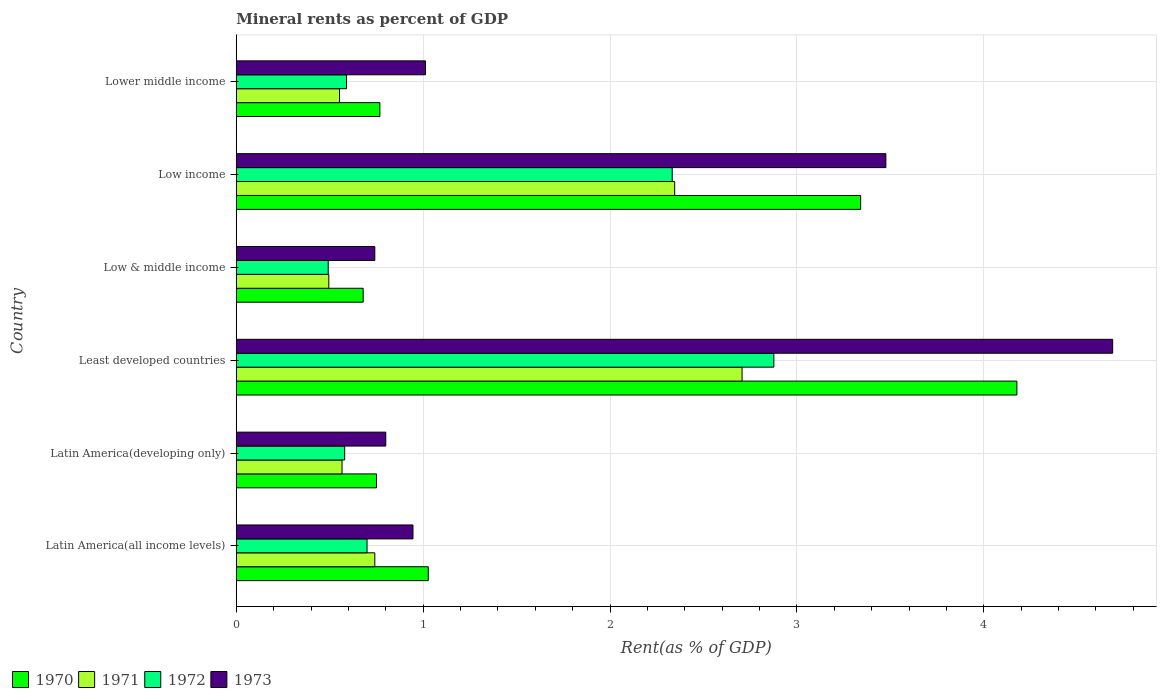How many groups of bars are there?
Your answer should be compact. 6. How many bars are there on the 5th tick from the top?
Give a very brief answer. 4. What is the label of the 3rd group of bars from the top?
Offer a very short reply. Low & middle income. What is the mineral rent in 1972 in Low & middle income?
Offer a terse response. 0.49. Across all countries, what is the maximum mineral rent in 1972?
Your answer should be very brief. 2.88. Across all countries, what is the minimum mineral rent in 1972?
Your response must be concise. 0.49. In which country was the mineral rent in 1972 maximum?
Ensure brevity in your answer.  Least developed countries. What is the total mineral rent in 1973 in the graph?
Make the answer very short. 11.67. What is the difference between the mineral rent in 1971 in Latin America(all income levels) and that in Low & middle income?
Provide a succinct answer. 0.25. What is the difference between the mineral rent in 1972 in Latin America(developing only) and the mineral rent in 1973 in Lower middle income?
Provide a succinct answer. -0.43. What is the average mineral rent in 1973 per country?
Offer a very short reply. 1.94. What is the difference between the mineral rent in 1972 and mineral rent in 1971 in Low & middle income?
Keep it short and to the point. -0. In how many countries, is the mineral rent in 1970 greater than 1.4 %?
Your answer should be very brief. 2. What is the ratio of the mineral rent in 1970 in Latin America(developing only) to that in Low income?
Your answer should be compact. 0.22. Is the mineral rent in 1971 in Latin America(all income levels) less than that in Low income?
Offer a very short reply. Yes. What is the difference between the highest and the second highest mineral rent in 1970?
Your answer should be very brief. 0.84. What is the difference between the highest and the lowest mineral rent in 1972?
Give a very brief answer. 2.38. In how many countries, is the mineral rent in 1972 greater than the average mineral rent in 1972 taken over all countries?
Provide a succinct answer. 2. What does the 2nd bar from the bottom in Latin America(developing only) represents?
Ensure brevity in your answer.  1971. Are all the bars in the graph horizontal?
Provide a succinct answer. Yes. How many countries are there in the graph?
Offer a very short reply. 6. Are the values on the major ticks of X-axis written in scientific E-notation?
Provide a short and direct response. No. Where does the legend appear in the graph?
Offer a very short reply. Bottom left. How are the legend labels stacked?
Offer a very short reply. Horizontal. What is the title of the graph?
Ensure brevity in your answer.  Mineral rents as percent of GDP. Does "2015" appear as one of the legend labels in the graph?
Your response must be concise. No. What is the label or title of the X-axis?
Offer a very short reply. Rent(as % of GDP). What is the Rent(as % of GDP) in 1970 in Latin America(all income levels)?
Offer a terse response. 1.03. What is the Rent(as % of GDP) of 1971 in Latin America(all income levels)?
Your answer should be very brief. 0.74. What is the Rent(as % of GDP) of 1972 in Latin America(all income levels)?
Your answer should be very brief. 0.7. What is the Rent(as % of GDP) of 1973 in Latin America(all income levels)?
Your answer should be very brief. 0.95. What is the Rent(as % of GDP) in 1970 in Latin America(developing only)?
Offer a terse response. 0.75. What is the Rent(as % of GDP) in 1971 in Latin America(developing only)?
Make the answer very short. 0.57. What is the Rent(as % of GDP) in 1972 in Latin America(developing only)?
Ensure brevity in your answer.  0.58. What is the Rent(as % of GDP) in 1973 in Latin America(developing only)?
Give a very brief answer. 0.8. What is the Rent(as % of GDP) of 1970 in Least developed countries?
Your response must be concise. 4.18. What is the Rent(as % of GDP) in 1971 in Least developed countries?
Provide a short and direct response. 2.71. What is the Rent(as % of GDP) of 1972 in Least developed countries?
Offer a terse response. 2.88. What is the Rent(as % of GDP) in 1973 in Least developed countries?
Your answer should be compact. 4.69. What is the Rent(as % of GDP) in 1970 in Low & middle income?
Your response must be concise. 0.68. What is the Rent(as % of GDP) of 1971 in Low & middle income?
Offer a terse response. 0.5. What is the Rent(as % of GDP) in 1972 in Low & middle income?
Keep it short and to the point. 0.49. What is the Rent(as % of GDP) of 1973 in Low & middle income?
Your answer should be very brief. 0.74. What is the Rent(as % of GDP) of 1970 in Low income?
Ensure brevity in your answer.  3.34. What is the Rent(as % of GDP) in 1971 in Low income?
Keep it short and to the point. 2.35. What is the Rent(as % of GDP) in 1972 in Low income?
Make the answer very short. 2.33. What is the Rent(as % of GDP) in 1973 in Low income?
Provide a short and direct response. 3.48. What is the Rent(as % of GDP) in 1970 in Lower middle income?
Offer a very short reply. 0.77. What is the Rent(as % of GDP) of 1971 in Lower middle income?
Provide a short and direct response. 0.55. What is the Rent(as % of GDP) in 1972 in Lower middle income?
Make the answer very short. 0.59. What is the Rent(as % of GDP) of 1973 in Lower middle income?
Provide a short and direct response. 1.01. Across all countries, what is the maximum Rent(as % of GDP) of 1970?
Make the answer very short. 4.18. Across all countries, what is the maximum Rent(as % of GDP) in 1971?
Offer a terse response. 2.71. Across all countries, what is the maximum Rent(as % of GDP) of 1972?
Provide a succinct answer. 2.88. Across all countries, what is the maximum Rent(as % of GDP) in 1973?
Your answer should be compact. 4.69. Across all countries, what is the minimum Rent(as % of GDP) of 1970?
Ensure brevity in your answer.  0.68. Across all countries, what is the minimum Rent(as % of GDP) in 1971?
Make the answer very short. 0.5. Across all countries, what is the minimum Rent(as % of GDP) of 1972?
Ensure brevity in your answer.  0.49. Across all countries, what is the minimum Rent(as % of GDP) of 1973?
Your answer should be very brief. 0.74. What is the total Rent(as % of GDP) of 1970 in the graph?
Your answer should be very brief. 10.74. What is the total Rent(as % of GDP) of 1971 in the graph?
Your response must be concise. 7.41. What is the total Rent(as % of GDP) in 1972 in the graph?
Your response must be concise. 7.57. What is the total Rent(as % of GDP) in 1973 in the graph?
Provide a succinct answer. 11.67. What is the difference between the Rent(as % of GDP) of 1970 in Latin America(all income levels) and that in Latin America(developing only)?
Your response must be concise. 0.28. What is the difference between the Rent(as % of GDP) in 1971 in Latin America(all income levels) and that in Latin America(developing only)?
Provide a succinct answer. 0.18. What is the difference between the Rent(as % of GDP) in 1972 in Latin America(all income levels) and that in Latin America(developing only)?
Your answer should be very brief. 0.12. What is the difference between the Rent(as % of GDP) of 1973 in Latin America(all income levels) and that in Latin America(developing only)?
Offer a very short reply. 0.15. What is the difference between the Rent(as % of GDP) in 1970 in Latin America(all income levels) and that in Least developed countries?
Your answer should be compact. -3.15. What is the difference between the Rent(as % of GDP) in 1971 in Latin America(all income levels) and that in Least developed countries?
Offer a very short reply. -1.97. What is the difference between the Rent(as % of GDP) of 1972 in Latin America(all income levels) and that in Least developed countries?
Your answer should be compact. -2.18. What is the difference between the Rent(as % of GDP) of 1973 in Latin America(all income levels) and that in Least developed countries?
Your answer should be very brief. -3.74. What is the difference between the Rent(as % of GDP) of 1970 in Latin America(all income levels) and that in Low & middle income?
Give a very brief answer. 0.35. What is the difference between the Rent(as % of GDP) in 1971 in Latin America(all income levels) and that in Low & middle income?
Offer a very short reply. 0.25. What is the difference between the Rent(as % of GDP) of 1972 in Latin America(all income levels) and that in Low & middle income?
Offer a terse response. 0.21. What is the difference between the Rent(as % of GDP) in 1973 in Latin America(all income levels) and that in Low & middle income?
Ensure brevity in your answer.  0.2. What is the difference between the Rent(as % of GDP) in 1970 in Latin America(all income levels) and that in Low income?
Offer a very short reply. -2.31. What is the difference between the Rent(as % of GDP) of 1971 in Latin America(all income levels) and that in Low income?
Your answer should be very brief. -1.6. What is the difference between the Rent(as % of GDP) in 1972 in Latin America(all income levels) and that in Low income?
Your answer should be very brief. -1.63. What is the difference between the Rent(as % of GDP) of 1973 in Latin America(all income levels) and that in Low income?
Your answer should be compact. -2.53. What is the difference between the Rent(as % of GDP) in 1970 in Latin America(all income levels) and that in Lower middle income?
Give a very brief answer. 0.26. What is the difference between the Rent(as % of GDP) in 1971 in Latin America(all income levels) and that in Lower middle income?
Your answer should be very brief. 0.19. What is the difference between the Rent(as % of GDP) of 1972 in Latin America(all income levels) and that in Lower middle income?
Provide a succinct answer. 0.11. What is the difference between the Rent(as % of GDP) in 1973 in Latin America(all income levels) and that in Lower middle income?
Your response must be concise. -0.07. What is the difference between the Rent(as % of GDP) in 1970 in Latin America(developing only) and that in Least developed countries?
Give a very brief answer. -3.43. What is the difference between the Rent(as % of GDP) in 1971 in Latin America(developing only) and that in Least developed countries?
Provide a succinct answer. -2.14. What is the difference between the Rent(as % of GDP) of 1972 in Latin America(developing only) and that in Least developed countries?
Provide a succinct answer. -2.3. What is the difference between the Rent(as % of GDP) of 1973 in Latin America(developing only) and that in Least developed countries?
Your answer should be very brief. -3.89. What is the difference between the Rent(as % of GDP) of 1970 in Latin America(developing only) and that in Low & middle income?
Provide a short and direct response. 0.07. What is the difference between the Rent(as % of GDP) of 1971 in Latin America(developing only) and that in Low & middle income?
Your answer should be very brief. 0.07. What is the difference between the Rent(as % of GDP) of 1972 in Latin America(developing only) and that in Low & middle income?
Your answer should be very brief. 0.09. What is the difference between the Rent(as % of GDP) of 1973 in Latin America(developing only) and that in Low & middle income?
Your answer should be very brief. 0.06. What is the difference between the Rent(as % of GDP) in 1970 in Latin America(developing only) and that in Low income?
Keep it short and to the point. -2.59. What is the difference between the Rent(as % of GDP) of 1971 in Latin America(developing only) and that in Low income?
Offer a terse response. -1.78. What is the difference between the Rent(as % of GDP) of 1972 in Latin America(developing only) and that in Low income?
Your answer should be very brief. -1.75. What is the difference between the Rent(as % of GDP) of 1973 in Latin America(developing only) and that in Low income?
Provide a succinct answer. -2.68. What is the difference between the Rent(as % of GDP) of 1970 in Latin America(developing only) and that in Lower middle income?
Your answer should be compact. -0.02. What is the difference between the Rent(as % of GDP) of 1971 in Latin America(developing only) and that in Lower middle income?
Provide a short and direct response. 0.01. What is the difference between the Rent(as % of GDP) of 1972 in Latin America(developing only) and that in Lower middle income?
Give a very brief answer. -0.01. What is the difference between the Rent(as % of GDP) in 1973 in Latin America(developing only) and that in Lower middle income?
Give a very brief answer. -0.21. What is the difference between the Rent(as % of GDP) in 1970 in Least developed countries and that in Low & middle income?
Provide a short and direct response. 3.5. What is the difference between the Rent(as % of GDP) of 1971 in Least developed countries and that in Low & middle income?
Offer a very short reply. 2.21. What is the difference between the Rent(as % of GDP) of 1972 in Least developed countries and that in Low & middle income?
Keep it short and to the point. 2.38. What is the difference between the Rent(as % of GDP) in 1973 in Least developed countries and that in Low & middle income?
Provide a short and direct response. 3.95. What is the difference between the Rent(as % of GDP) in 1970 in Least developed countries and that in Low income?
Keep it short and to the point. 0.84. What is the difference between the Rent(as % of GDP) in 1971 in Least developed countries and that in Low income?
Provide a short and direct response. 0.36. What is the difference between the Rent(as % of GDP) of 1972 in Least developed countries and that in Low income?
Your answer should be very brief. 0.54. What is the difference between the Rent(as % of GDP) in 1973 in Least developed countries and that in Low income?
Give a very brief answer. 1.21. What is the difference between the Rent(as % of GDP) of 1970 in Least developed countries and that in Lower middle income?
Keep it short and to the point. 3.41. What is the difference between the Rent(as % of GDP) in 1971 in Least developed countries and that in Lower middle income?
Your answer should be very brief. 2.15. What is the difference between the Rent(as % of GDP) in 1972 in Least developed countries and that in Lower middle income?
Provide a short and direct response. 2.29. What is the difference between the Rent(as % of GDP) of 1973 in Least developed countries and that in Lower middle income?
Your response must be concise. 3.68. What is the difference between the Rent(as % of GDP) in 1970 in Low & middle income and that in Low income?
Give a very brief answer. -2.66. What is the difference between the Rent(as % of GDP) in 1971 in Low & middle income and that in Low income?
Provide a succinct answer. -1.85. What is the difference between the Rent(as % of GDP) in 1972 in Low & middle income and that in Low income?
Give a very brief answer. -1.84. What is the difference between the Rent(as % of GDP) of 1973 in Low & middle income and that in Low income?
Ensure brevity in your answer.  -2.73. What is the difference between the Rent(as % of GDP) of 1970 in Low & middle income and that in Lower middle income?
Keep it short and to the point. -0.09. What is the difference between the Rent(as % of GDP) in 1971 in Low & middle income and that in Lower middle income?
Ensure brevity in your answer.  -0.06. What is the difference between the Rent(as % of GDP) in 1972 in Low & middle income and that in Lower middle income?
Offer a very short reply. -0.1. What is the difference between the Rent(as % of GDP) of 1973 in Low & middle income and that in Lower middle income?
Keep it short and to the point. -0.27. What is the difference between the Rent(as % of GDP) in 1970 in Low income and that in Lower middle income?
Make the answer very short. 2.57. What is the difference between the Rent(as % of GDP) of 1971 in Low income and that in Lower middle income?
Provide a succinct answer. 1.79. What is the difference between the Rent(as % of GDP) of 1972 in Low income and that in Lower middle income?
Your answer should be compact. 1.74. What is the difference between the Rent(as % of GDP) in 1973 in Low income and that in Lower middle income?
Offer a terse response. 2.46. What is the difference between the Rent(as % of GDP) of 1970 in Latin America(all income levels) and the Rent(as % of GDP) of 1971 in Latin America(developing only)?
Provide a succinct answer. 0.46. What is the difference between the Rent(as % of GDP) in 1970 in Latin America(all income levels) and the Rent(as % of GDP) in 1972 in Latin America(developing only)?
Offer a very short reply. 0.45. What is the difference between the Rent(as % of GDP) of 1970 in Latin America(all income levels) and the Rent(as % of GDP) of 1973 in Latin America(developing only)?
Your response must be concise. 0.23. What is the difference between the Rent(as % of GDP) of 1971 in Latin America(all income levels) and the Rent(as % of GDP) of 1972 in Latin America(developing only)?
Provide a short and direct response. 0.16. What is the difference between the Rent(as % of GDP) of 1971 in Latin America(all income levels) and the Rent(as % of GDP) of 1973 in Latin America(developing only)?
Your answer should be very brief. -0.06. What is the difference between the Rent(as % of GDP) of 1972 in Latin America(all income levels) and the Rent(as % of GDP) of 1973 in Latin America(developing only)?
Provide a short and direct response. -0.1. What is the difference between the Rent(as % of GDP) of 1970 in Latin America(all income levels) and the Rent(as % of GDP) of 1971 in Least developed countries?
Provide a short and direct response. -1.68. What is the difference between the Rent(as % of GDP) of 1970 in Latin America(all income levels) and the Rent(as % of GDP) of 1972 in Least developed countries?
Make the answer very short. -1.85. What is the difference between the Rent(as % of GDP) in 1970 in Latin America(all income levels) and the Rent(as % of GDP) in 1973 in Least developed countries?
Give a very brief answer. -3.66. What is the difference between the Rent(as % of GDP) of 1971 in Latin America(all income levels) and the Rent(as % of GDP) of 1972 in Least developed countries?
Offer a terse response. -2.14. What is the difference between the Rent(as % of GDP) of 1971 in Latin America(all income levels) and the Rent(as % of GDP) of 1973 in Least developed countries?
Provide a succinct answer. -3.95. What is the difference between the Rent(as % of GDP) of 1972 in Latin America(all income levels) and the Rent(as % of GDP) of 1973 in Least developed countries?
Give a very brief answer. -3.99. What is the difference between the Rent(as % of GDP) of 1970 in Latin America(all income levels) and the Rent(as % of GDP) of 1971 in Low & middle income?
Ensure brevity in your answer.  0.53. What is the difference between the Rent(as % of GDP) in 1970 in Latin America(all income levels) and the Rent(as % of GDP) in 1972 in Low & middle income?
Give a very brief answer. 0.54. What is the difference between the Rent(as % of GDP) of 1970 in Latin America(all income levels) and the Rent(as % of GDP) of 1973 in Low & middle income?
Your response must be concise. 0.29. What is the difference between the Rent(as % of GDP) in 1971 in Latin America(all income levels) and the Rent(as % of GDP) in 1972 in Low & middle income?
Provide a short and direct response. 0.25. What is the difference between the Rent(as % of GDP) of 1972 in Latin America(all income levels) and the Rent(as % of GDP) of 1973 in Low & middle income?
Keep it short and to the point. -0.04. What is the difference between the Rent(as % of GDP) of 1970 in Latin America(all income levels) and the Rent(as % of GDP) of 1971 in Low income?
Offer a terse response. -1.32. What is the difference between the Rent(as % of GDP) in 1970 in Latin America(all income levels) and the Rent(as % of GDP) in 1972 in Low income?
Keep it short and to the point. -1.31. What is the difference between the Rent(as % of GDP) of 1970 in Latin America(all income levels) and the Rent(as % of GDP) of 1973 in Low income?
Make the answer very short. -2.45. What is the difference between the Rent(as % of GDP) of 1971 in Latin America(all income levels) and the Rent(as % of GDP) of 1972 in Low income?
Make the answer very short. -1.59. What is the difference between the Rent(as % of GDP) of 1971 in Latin America(all income levels) and the Rent(as % of GDP) of 1973 in Low income?
Give a very brief answer. -2.73. What is the difference between the Rent(as % of GDP) of 1972 in Latin America(all income levels) and the Rent(as % of GDP) of 1973 in Low income?
Provide a short and direct response. -2.78. What is the difference between the Rent(as % of GDP) of 1970 in Latin America(all income levels) and the Rent(as % of GDP) of 1971 in Lower middle income?
Your answer should be compact. 0.47. What is the difference between the Rent(as % of GDP) of 1970 in Latin America(all income levels) and the Rent(as % of GDP) of 1972 in Lower middle income?
Offer a very short reply. 0.44. What is the difference between the Rent(as % of GDP) of 1970 in Latin America(all income levels) and the Rent(as % of GDP) of 1973 in Lower middle income?
Your answer should be compact. 0.01. What is the difference between the Rent(as % of GDP) in 1971 in Latin America(all income levels) and the Rent(as % of GDP) in 1972 in Lower middle income?
Keep it short and to the point. 0.15. What is the difference between the Rent(as % of GDP) of 1971 in Latin America(all income levels) and the Rent(as % of GDP) of 1973 in Lower middle income?
Keep it short and to the point. -0.27. What is the difference between the Rent(as % of GDP) in 1972 in Latin America(all income levels) and the Rent(as % of GDP) in 1973 in Lower middle income?
Your answer should be very brief. -0.31. What is the difference between the Rent(as % of GDP) of 1970 in Latin America(developing only) and the Rent(as % of GDP) of 1971 in Least developed countries?
Your response must be concise. -1.96. What is the difference between the Rent(as % of GDP) in 1970 in Latin America(developing only) and the Rent(as % of GDP) in 1972 in Least developed countries?
Keep it short and to the point. -2.13. What is the difference between the Rent(as % of GDP) in 1970 in Latin America(developing only) and the Rent(as % of GDP) in 1973 in Least developed countries?
Give a very brief answer. -3.94. What is the difference between the Rent(as % of GDP) in 1971 in Latin America(developing only) and the Rent(as % of GDP) in 1972 in Least developed countries?
Your answer should be compact. -2.31. What is the difference between the Rent(as % of GDP) of 1971 in Latin America(developing only) and the Rent(as % of GDP) of 1973 in Least developed countries?
Offer a terse response. -4.12. What is the difference between the Rent(as % of GDP) of 1972 in Latin America(developing only) and the Rent(as % of GDP) of 1973 in Least developed countries?
Give a very brief answer. -4.11. What is the difference between the Rent(as % of GDP) of 1970 in Latin America(developing only) and the Rent(as % of GDP) of 1971 in Low & middle income?
Ensure brevity in your answer.  0.26. What is the difference between the Rent(as % of GDP) in 1970 in Latin America(developing only) and the Rent(as % of GDP) in 1972 in Low & middle income?
Provide a short and direct response. 0.26. What is the difference between the Rent(as % of GDP) in 1970 in Latin America(developing only) and the Rent(as % of GDP) in 1973 in Low & middle income?
Provide a succinct answer. 0.01. What is the difference between the Rent(as % of GDP) in 1971 in Latin America(developing only) and the Rent(as % of GDP) in 1972 in Low & middle income?
Offer a terse response. 0.07. What is the difference between the Rent(as % of GDP) in 1971 in Latin America(developing only) and the Rent(as % of GDP) in 1973 in Low & middle income?
Give a very brief answer. -0.18. What is the difference between the Rent(as % of GDP) in 1972 in Latin America(developing only) and the Rent(as % of GDP) in 1973 in Low & middle income?
Offer a terse response. -0.16. What is the difference between the Rent(as % of GDP) of 1970 in Latin America(developing only) and the Rent(as % of GDP) of 1971 in Low income?
Provide a succinct answer. -1.6. What is the difference between the Rent(as % of GDP) in 1970 in Latin America(developing only) and the Rent(as % of GDP) in 1972 in Low income?
Make the answer very short. -1.58. What is the difference between the Rent(as % of GDP) in 1970 in Latin America(developing only) and the Rent(as % of GDP) in 1973 in Low income?
Your answer should be very brief. -2.73. What is the difference between the Rent(as % of GDP) of 1971 in Latin America(developing only) and the Rent(as % of GDP) of 1972 in Low income?
Provide a succinct answer. -1.77. What is the difference between the Rent(as % of GDP) of 1971 in Latin America(developing only) and the Rent(as % of GDP) of 1973 in Low income?
Provide a short and direct response. -2.91. What is the difference between the Rent(as % of GDP) in 1972 in Latin America(developing only) and the Rent(as % of GDP) in 1973 in Low income?
Make the answer very short. -2.9. What is the difference between the Rent(as % of GDP) in 1970 in Latin America(developing only) and the Rent(as % of GDP) in 1971 in Lower middle income?
Your answer should be very brief. 0.2. What is the difference between the Rent(as % of GDP) of 1970 in Latin America(developing only) and the Rent(as % of GDP) of 1972 in Lower middle income?
Your answer should be compact. 0.16. What is the difference between the Rent(as % of GDP) of 1970 in Latin America(developing only) and the Rent(as % of GDP) of 1973 in Lower middle income?
Keep it short and to the point. -0.26. What is the difference between the Rent(as % of GDP) of 1971 in Latin America(developing only) and the Rent(as % of GDP) of 1972 in Lower middle income?
Give a very brief answer. -0.02. What is the difference between the Rent(as % of GDP) of 1971 in Latin America(developing only) and the Rent(as % of GDP) of 1973 in Lower middle income?
Provide a succinct answer. -0.45. What is the difference between the Rent(as % of GDP) of 1972 in Latin America(developing only) and the Rent(as % of GDP) of 1973 in Lower middle income?
Give a very brief answer. -0.43. What is the difference between the Rent(as % of GDP) of 1970 in Least developed countries and the Rent(as % of GDP) of 1971 in Low & middle income?
Your answer should be compact. 3.68. What is the difference between the Rent(as % of GDP) in 1970 in Least developed countries and the Rent(as % of GDP) in 1972 in Low & middle income?
Your response must be concise. 3.69. What is the difference between the Rent(as % of GDP) in 1970 in Least developed countries and the Rent(as % of GDP) in 1973 in Low & middle income?
Offer a very short reply. 3.44. What is the difference between the Rent(as % of GDP) of 1971 in Least developed countries and the Rent(as % of GDP) of 1972 in Low & middle income?
Provide a short and direct response. 2.21. What is the difference between the Rent(as % of GDP) in 1971 in Least developed countries and the Rent(as % of GDP) in 1973 in Low & middle income?
Make the answer very short. 1.97. What is the difference between the Rent(as % of GDP) in 1972 in Least developed countries and the Rent(as % of GDP) in 1973 in Low & middle income?
Ensure brevity in your answer.  2.14. What is the difference between the Rent(as % of GDP) in 1970 in Least developed countries and the Rent(as % of GDP) in 1971 in Low income?
Your response must be concise. 1.83. What is the difference between the Rent(as % of GDP) of 1970 in Least developed countries and the Rent(as % of GDP) of 1972 in Low income?
Offer a terse response. 1.84. What is the difference between the Rent(as % of GDP) in 1970 in Least developed countries and the Rent(as % of GDP) in 1973 in Low income?
Offer a very short reply. 0.7. What is the difference between the Rent(as % of GDP) of 1971 in Least developed countries and the Rent(as % of GDP) of 1972 in Low income?
Make the answer very short. 0.37. What is the difference between the Rent(as % of GDP) in 1971 in Least developed countries and the Rent(as % of GDP) in 1973 in Low income?
Your answer should be very brief. -0.77. What is the difference between the Rent(as % of GDP) in 1972 in Least developed countries and the Rent(as % of GDP) in 1973 in Low income?
Your answer should be compact. -0.6. What is the difference between the Rent(as % of GDP) of 1970 in Least developed countries and the Rent(as % of GDP) of 1971 in Lower middle income?
Provide a short and direct response. 3.62. What is the difference between the Rent(as % of GDP) in 1970 in Least developed countries and the Rent(as % of GDP) in 1972 in Lower middle income?
Your response must be concise. 3.59. What is the difference between the Rent(as % of GDP) in 1970 in Least developed countries and the Rent(as % of GDP) in 1973 in Lower middle income?
Give a very brief answer. 3.16. What is the difference between the Rent(as % of GDP) in 1971 in Least developed countries and the Rent(as % of GDP) in 1972 in Lower middle income?
Provide a succinct answer. 2.12. What is the difference between the Rent(as % of GDP) in 1971 in Least developed countries and the Rent(as % of GDP) in 1973 in Lower middle income?
Provide a short and direct response. 1.69. What is the difference between the Rent(as % of GDP) in 1972 in Least developed countries and the Rent(as % of GDP) in 1973 in Lower middle income?
Ensure brevity in your answer.  1.86. What is the difference between the Rent(as % of GDP) of 1970 in Low & middle income and the Rent(as % of GDP) of 1971 in Low income?
Offer a terse response. -1.67. What is the difference between the Rent(as % of GDP) of 1970 in Low & middle income and the Rent(as % of GDP) of 1972 in Low income?
Offer a very short reply. -1.65. What is the difference between the Rent(as % of GDP) of 1970 in Low & middle income and the Rent(as % of GDP) of 1973 in Low income?
Offer a terse response. -2.8. What is the difference between the Rent(as % of GDP) of 1971 in Low & middle income and the Rent(as % of GDP) of 1972 in Low income?
Offer a terse response. -1.84. What is the difference between the Rent(as % of GDP) of 1971 in Low & middle income and the Rent(as % of GDP) of 1973 in Low income?
Offer a very short reply. -2.98. What is the difference between the Rent(as % of GDP) in 1972 in Low & middle income and the Rent(as % of GDP) in 1973 in Low income?
Give a very brief answer. -2.98. What is the difference between the Rent(as % of GDP) of 1970 in Low & middle income and the Rent(as % of GDP) of 1971 in Lower middle income?
Provide a short and direct response. 0.13. What is the difference between the Rent(as % of GDP) in 1970 in Low & middle income and the Rent(as % of GDP) in 1972 in Lower middle income?
Make the answer very short. 0.09. What is the difference between the Rent(as % of GDP) in 1970 in Low & middle income and the Rent(as % of GDP) in 1973 in Lower middle income?
Offer a terse response. -0.33. What is the difference between the Rent(as % of GDP) of 1971 in Low & middle income and the Rent(as % of GDP) of 1972 in Lower middle income?
Ensure brevity in your answer.  -0.09. What is the difference between the Rent(as % of GDP) in 1971 in Low & middle income and the Rent(as % of GDP) in 1973 in Lower middle income?
Your answer should be compact. -0.52. What is the difference between the Rent(as % of GDP) of 1972 in Low & middle income and the Rent(as % of GDP) of 1973 in Lower middle income?
Your response must be concise. -0.52. What is the difference between the Rent(as % of GDP) in 1970 in Low income and the Rent(as % of GDP) in 1971 in Lower middle income?
Ensure brevity in your answer.  2.79. What is the difference between the Rent(as % of GDP) of 1970 in Low income and the Rent(as % of GDP) of 1972 in Lower middle income?
Offer a terse response. 2.75. What is the difference between the Rent(as % of GDP) in 1970 in Low income and the Rent(as % of GDP) in 1973 in Lower middle income?
Give a very brief answer. 2.33. What is the difference between the Rent(as % of GDP) of 1971 in Low income and the Rent(as % of GDP) of 1972 in Lower middle income?
Your answer should be compact. 1.76. What is the difference between the Rent(as % of GDP) in 1971 in Low income and the Rent(as % of GDP) in 1973 in Lower middle income?
Your response must be concise. 1.33. What is the difference between the Rent(as % of GDP) in 1972 in Low income and the Rent(as % of GDP) in 1973 in Lower middle income?
Ensure brevity in your answer.  1.32. What is the average Rent(as % of GDP) in 1970 per country?
Your answer should be compact. 1.79. What is the average Rent(as % of GDP) of 1971 per country?
Your answer should be very brief. 1.23. What is the average Rent(as % of GDP) in 1972 per country?
Ensure brevity in your answer.  1.26. What is the average Rent(as % of GDP) of 1973 per country?
Ensure brevity in your answer.  1.94. What is the difference between the Rent(as % of GDP) of 1970 and Rent(as % of GDP) of 1971 in Latin America(all income levels)?
Make the answer very short. 0.29. What is the difference between the Rent(as % of GDP) in 1970 and Rent(as % of GDP) in 1972 in Latin America(all income levels)?
Offer a very short reply. 0.33. What is the difference between the Rent(as % of GDP) of 1970 and Rent(as % of GDP) of 1973 in Latin America(all income levels)?
Make the answer very short. 0.08. What is the difference between the Rent(as % of GDP) of 1971 and Rent(as % of GDP) of 1972 in Latin America(all income levels)?
Make the answer very short. 0.04. What is the difference between the Rent(as % of GDP) of 1971 and Rent(as % of GDP) of 1973 in Latin America(all income levels)?
Your answer should be compact. -0.2. What is the difference between the Rent(as % of GDP) of 1972 and Rent(as % of GDP) of 1973 in Latin America(all income levels)?
Your response must be concise. -0.25. What is the difference between the Rent(as % of GDP) of 1970 and Rent(as % of GDP) of 1971 in Latin America(developing only)?
Provide a succinct answer. 0.18. What is the difference between the Rent(as % of GDP) in 1970 and Rent(as % of GDP) in 1972 in Latin America(developing only)?
Your answer should be very brief. 0.17. What is the difference between the Rent(as % of GDP) of 1970 and Rent(as % of GDP) of 1973 in Latin America(developing only)?
Offer a terse response. -0.05. What is the difference between the Rent(as % of GDP) of 1971 and Rent(as % of GDP) of 1972 in Latin America(developing only)?
Give a very brief answer. -0.01. What is the difference between the Rent(as % of GDP) of 1971 and Rent(as % of GDP) of 1973 in Latin America(developing only)?
Offer a terse response. -0.23. What is the difference between the Rent(as % of GDP) in 1972 and Rent(as % of GDP) in 1973 in Latin America(developing only)?
Your answer should be very brief. -0.22. What is the difference between the Rent(as % of GDP) of 1970 and Rent(as % of GDP) of 1971 in Least developed countries?
Offer a terse response. 1.47. What is the difference between the Rent(as % of GDP) in 1970 and Rent(as % of GDP) in 1972 in Least developed countries?
Provide a succinct answer. 1.3. What is the difference between the Rent(as % of GDP) in 1970 and Rent(as % of GDP) in 1973 in Least developed countries?
Make the answer very short. -0.51. What is the difference between the Rent(as % of GDP) in 1971 and Rent(as % of GDP) in 1972 in Least developed countries?
Offer a very short reply. -0.17. What is the difference between the Rent(as % of GDP) in 1971 and Rent(as % of GDP) in 1973 in Least developed countries?
Keep it short and to the point. -1.98. What is the difference between the Rent(as % of GDP) in 1972 and Rent(as % of GDP) in 1973 in Least developed countries?
Your answer should be compact. -1.81. What is the difference between the Rent(as % of GDP) in 1970 and Rent(as % of GDP) in 1971 in Low & middle income?
Your answer should be compact. 0.18. What is the difference between the Rent(as % of GDP) in 1970 and Rent(as % of GDP) in 1972 in Low & middle income?
Offer a very short reply. 0.19. What is the difference between the Rent(as % of GDP) in 1970 and Rent(as % of GDP) in 1973 in Low & middle income?
Ensure brevity in your answer.  -0.06. What is the difference between the Rent(as % of GDP) of 1971 and Rent(as % of GDP) of 1972 in Low & middle income?
Offer a very short reply. 0. What is the difference between the Rent(as % of GDP) of 1971 and Rent(as % of GDP) of 1973 in Low & middle income?
Provide a succinct answer. -0.25. What is the difference between the Rent(as % of GDP) of 1972 and Rent(as % of GDP) of 1973 in Low & middle income?
Provide a short and direct response. -0.25. What is the difference between the Rent(as % of GDP) in 1970 and Rent(as % of GDP) in 1972 in Low income?
Your answer should be very brief. 1.01. What is the difference between the Rent(as % of GDP) of 1970 and Rent(as % of GDP) of 1973 in Low income?
Your answer should be compact. -0.14. What is the difference between the Rent(as % of GDP) in 1971 and Rent(as % of GDP) in 1972 in Low income?
Your response must be concise. 0.01. What is the difference between the Rent(as % of GDP) of 1971 and Rent(as % of GDP) of 1973 in Low income?
Ensure brevity in your answer.  -1.13. What is the difference between the Rent(as % of GDP) in 1972 and Rent(as % of GDP) in 1973 in Low income?
Provide a short and direct response. -1.14. What is the difference between the Rent(as % of GDP) in 1970 and Rent(as % of GDP) in 1971 in Lower middle income?
Keep it short and to the point. 0.22. What is the difference between the Rent(as % of GDP) in 1970 and Rent(as % of GDP) in 1972 in Lower middle income?
Provide a succinct answer. 0.18. What is the difference between the Rent(as % of GDP) in 1970 and Rent(as % of GDP) in 1973 in Lower middle income?
Provide a short and direct response. -0.24. What is the difference between the Rent(as % of GDP) in 1971 and Rent(as % of GDP) in 1972 in Lower middle income?
Offer a terse response. -0.04. What is the difference between the Rent(as % of GDP) of 1971 and Rent(as % of GDP) of 1973 in Lower middle income?
Provide a succinct answer. -0.46. What is the difference between the Rent(as % of GDP) in 1972 and Rent(as % of GDP) in 1973 in Lower middle income?
Your answer should be compact. -0.42. What is the ratio of the Rent(as % of GDP) in 1970 in Latin America(all income levels) to that in Latin America(developing only)?
Provide a short and direct response. 1.37. What is the ratio of the Rent(as % of GDP) in 1971 in Latin America(all income levels) to that in Latin America(developing only)?
Provide a short and direct response. 1.31. What is the ratio of the Rent(as % of GDP) of 1972 in Latin America(all income levels) to that in Latin America(developing only)?
Your answer should be compact. 1.21. What is the ratio of the Rent(as % of GDP) in 1973 in Latin America(all income levels) to that in Latin America(developing only)?
Your answer should be compact. 1.18. What is the ratio of the Rent(as % of GDP) in 1970 in Latin America(all income levels) to that in Least developed countries?
Provide a succinct answer. 0.25. What is the ratio of the Rent(as % of GDP) in 1971 in Latin America(all income levels) to that in Least developed countries?
Your response must be concise. 0.27. What is the ratio of the Rent(as % of GDP) of 1972 in Latin America(all income levels) to that in Least developed countries?
Provide a succinct answer. 0.24. What is the ratio of the Rent(as % of GDP) in 1973 in Latin America(all income levels) to that in Least developed countries?
Offer a terse response. 0.2. What is the ratio of the Rent(as % of GDP) of 1970 in Latin America(all income levels) to that in Low & middle income?
Provide a short and direct response. 1.51. What is the ratio of the Rent(as % of GDP) in 1971 in Latin America(all income levels) to that in Low & middle income?
Keep it short and to the point. 1.5. What is the ratio of the Rent(as % of GDP) of 1972 in Latin America(all income levels) to that in Low & middle income?
Offer a very short reply. 1.42. What is the ratio of the Rent(as % of GDP) in 1973 in Latin America(all income levels) to that in Low & middle income?
Offer a terse response. 1.28. What is the ratio of the Rent(as % of GDP) of 1970 in Latin America(all income levels) to that in Low income?
Your answer should be very brief. 0.31. What is the ratio of the Rent(as % of GDP) in 1971 in Latin America(all income levels) to that in Low income?
Your answer should be compact. 0.32. What is the ratio of the Rent(as % of GDP) of 1973 in Latin America(all income levels) to that in Low income?
Give a very brief answer. 0.27. What is the ratio of the Rent(as % of GDP) in 1970 in Latin America(all income levels) to that in Lower middle income?
Offer a terse response. 1.34. What is the ratio of the Rent(as % of GDP) in 1971 in Latin America(all income levels) to that in Lower middle income?
Provide a succinct answer. 1.34. What is the ratio of the Rent(as % of GDP) in 1972 in Latin America(all income levels) to that in Lower middle income?
Provide a short and direct response. 1.19. What is the ratio of the Rent(as % of GDP) in 1973 in Latin America(all income levels) to that in Lower middle income?
Offer a very short reply. 0.93. What is the ratio of the Rent(as % of GDP) in 1970 in Latin America(developing only) to that in Least developed countries?
Ensure brevity in your answer.  0.18. What is the ratio of the Rent(as % of GDP) in 1971 in Latin America(developing only) to that in Least developed countries?
Your answer should be very brief. 0.21. What is the ratio of the Rent(as % of GDP) of 1972 in Latin America(developing only) to that in Least developed countries?
Your answer should be compact. 0.2. What is the ratio of the Rent(as % of GDP) of 1973 in Latin America(developing only) to that in Least developed countries?
Give a very brief answer. 0.17. What is the ratio of the Rent(as % of GDP) in 1970 in Latin America(developing only) to that in Low & middle income?
Provide a succinct answer. 1.1. What is the ratio of the Rent(as % of GDP) in 1971 in Latin America(developing only) to that in Low & middle income?
Make the answer very short. 1.14. What is the ratio of the Rent(as % of GDP) in 1972 in Latin America(developing only) to that in Low & middle income?
Your answer should be very brief. 1.18. What is the ratio of the Rent(as % of GDP) of 1973 in Latin America(developing only) to that in Low & middle income?
Provide a succinct answer. 1.08. What is the ratio of the Rent(as % of GDP) in 1970 in Latin America(developing only) to that in Low income?
Ensure brevity in your answer.  0.22. What is the ratio of the Rent(as % of GDP) of 1971 in Latin America(developing only) to that in Low income?
Make the answer very short. 0.24. What is the ratio of the Rent(as % of GDP) in 1972 in Latin America(developing only) to that in Low income?
Offer a terse response. 0.25. What is the ratio of the Rent(as % of GDP) in 1973 in Latin America(developing only) to that in Low income?
Your response must be concise. 0.23. What is the ratio of the Rent(as % of GDP) of 1970 in Latin America(developing only) to that in Lower middle income?
Your answer should be very brief. 0.98. What is the ratio of the Rent(as % of GDP) of 1971 in Latin America(developing only) to that in Lower middle income?
Your response must be concise. 1.02. What is the ratio of the Rent(as % of GDP) in 1972 in Latin America(developing only) to that in Lower middle income?
Your answer should be very brief. 0.98. What is the ratio of the Rent(as % of GDP) in 1973 in Latin America(developing only) to that in Lower middle income?
Your answer should be compact. 0.79. What is the ratio of the Rent(as % of GDP) in 1970 in Least developed countries to that in Low & middle income?
Keep it short and to the point. 6.15. What is the ratio of the Rent(as % of GDP) of 1971 in Least developed countries to that in Low & middle income?
Ensure brevity in your answer.  5.46. What is the ratio of the Rent(as % of GDP) in 1972 in Least developed countries to that in Low & middle income?
Your answer should be compact. 5.85. What is the ratio of the Rent(as % of GDP) in 1973 in Least developed countries to that in Low & middle income?
Your answer should be very brief. 6.33. What is the ratio of the Rent(as % of GDP) of 1970 in Least developed countries to that in Low income?
Offer a very short reply. 1.25. What is the ratio of the Rent(as % of GDP) in 1971 in Least developed countries to that in Low income?
Give a very brief answer. 1.15. What is the ratio of the Rent(as % of GDP) of 1972 in Least developed countries to that in Low income?
Make the answer very short. 1.23. What is the ratio of the Rent(as % of GDP) in 1973 in Least developed countries to that in Low income?
Provide a short and direct response. 1.35. What is the ratio of the Rent(as % of GDP) in 1970 in Least developed countries to that in Lower middle income?
Your answer should be compact. 5.44. What is the ratio of the Rent(as % of GDP) in 1971 in Least developed countries to that in Lower middle income?
Make the answer very short. 4.9. What is the ratio of the Rent(as % of GDP) in 1972 in Least developed countries to that in Lower middle income?
Your answer should be very brief. 4.87. What is the ratio of the Rent(as % of GDP) in 1973 in Least developed countries to that in Lower middle income?
Give a very brief answer. 4.63. What is the ratio of the Rent(as % of GDP) of 1970 in Low & middle income to that in Low income?
Keep it short and to the point. 0.2. What is the ratio of the Rent(as % of GDP) in 1971 in Low & middle income to that in Low income?
Offer a very short reply. 0.21. What is the ratio of the Rent(as % of GDP) in 1972 in Low & middle income to that in Low income?
Provide a short and direct response. 0.21. What is the ratio of the Rent(as % of GDP) in 1973 in Low & middle income to that in Low income?
Your response must be concise. 0.21. What is the ratio of the Rent(as % of GDP) of 1970 in Low & middle income to that in Lower middle income?
Provide a succinct answer. 0.88. What is the ratio of the Rent(as % of GDP) of 1971 in Low & middle income to that in Lower middle income?
Provide a succinct answer. 0.9. What is the ratio of the Rent(as % of GDP) in 1972 in Low & middle income to that in Lower middle income?
Your response must be concise. 0.83. What is the ratio of the Rent(as % of GDP) in 1973 in Low & middle income to that in Lower middle income?
Offer a terse response. 0.73. What is the ratio of the Rent(as % of GDP) of 1970 in Low income to that in Lower middle income?
Keep it short and to the point. 4.35. What is the ratio of the Rent(as % of GDP) of 1971 in Low income to that in Lower middle income?
Provide a short and direct response. 4.25. What is the ratio of the Rent(as % of GDP) in 1972 in Low income to that in Lower middle income?
Keep it short and to the point. 3.95. What is the ratio of the Rent(as % of GDP) in 1973 in Low income to that in Lower middle income?
Your answer should be very brief. 3.43. What is the difference between the highest and the second highest Rent(as % of GDP) in 1970?
Provide a short and direct response. 0.84. What is the difference between the highest and the second highest Rent(as % of GDP) of 1971?
Offer a terse response. 0.36. What is the difference between the highest and the second highest Rent(as % of GDP) in 1972?
Ensure brevity in your answer.  0.54. What is the difference between the highest and the second highest Rent(as % of GDP) in 1973?
Ensure brevity in your answer.  1.21. What is the difference between the highest and the lowest Rent(as % of GDP) in 1970?
Offer a terse response. 3.5. What is the difference between the highest and the lowest Rent(as % of GDP) in 1971?
Provide a succinct answer. 2.21. What is the difference between the highest and the lowest Rent(as % of GDP) in 1972?
Your answer should be compact. 2.38. What is the difference between the highest and the lowest Rent(as % of GDP) in 1973?
Provide a succinct answer. 3.95. 